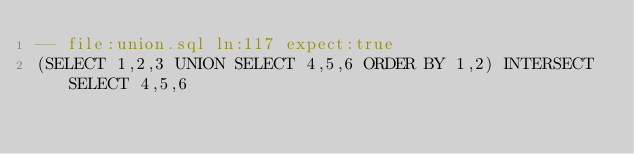<code> <loc_0><loc_0><loc_500><loc_500><_SQL_>-- file:union.sql ln:117 expect:true
(SELECT 1,2,3 UNION SELECT 4,5,6 ORDER BY 1,2) INTERSECT SELECT 4,5,6
</code> 